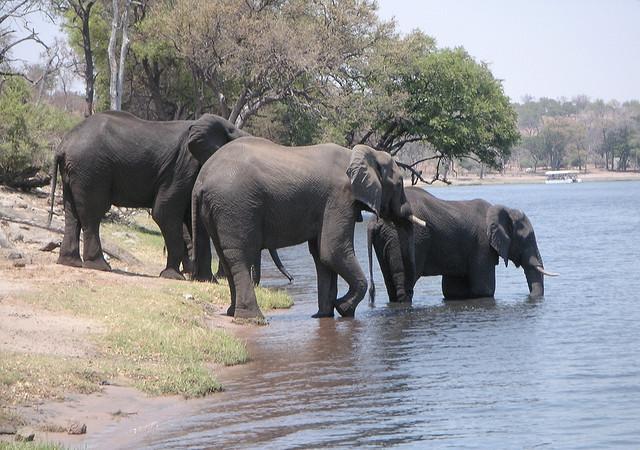What time of day is it?
Answer briefly. Morning. How many elephants are in the water?
Quick response, please. 2. How many tails can you see in this picture?
Concise answer only. 3. 